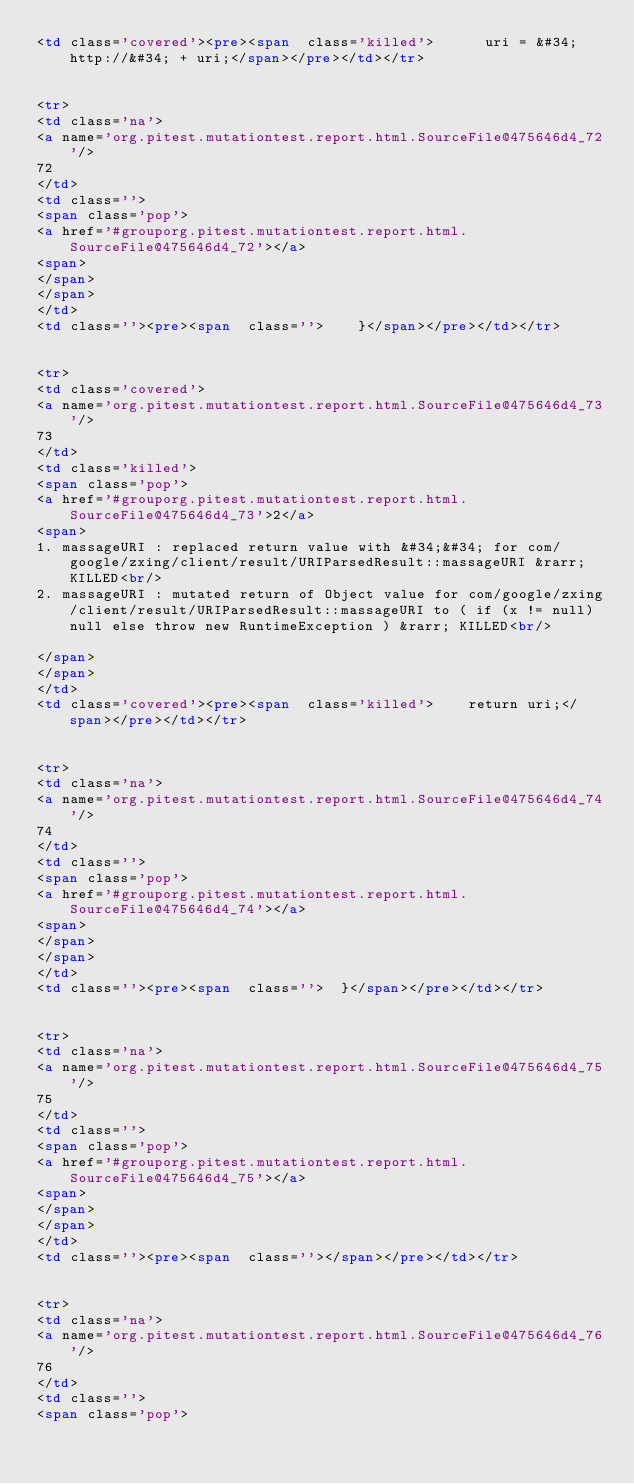Convert code to text. <code><loc_0><loc_0><loc_500><loc_500><_HTML_><td class='covered'><pre><span  class='killed'>      uri = &#34;http://&#34; + uri;</span></pre></td></tr>


<tr>
<td class='na'>
<a name='org.pitest.mutationtest.report.html.SourceFile@475646d4_72'/>
72
</td>
<td class=''>
<span class='pop'>
<a href='#grouporg.pitest.mutationtest.report.html.SourceFile@475646d4_72'></a>
<span>
</span>
</span>
</td>
<td class=''><pre><span  class=''>    }</span></pre></td></tr>


<tr>
<td class='covered'>
<a name='org.pitest.mutationtest.report.html.SourceFile@475646d4_73'/>
73
</td>
<td class='killed'>
<span class='pop'>
<a href='#grouporg.pitest.mutationtest.report.html.SourceFile@475646d4_73'>2</a>
<span>
1. massageURI : replaced return value with &#34;&#34; for com/google/zxing/client/result/URIParsedResult::massageURI &rarr; KILLED<br/>
2. massageURI : mutated return of Object value for com/google/zxing/client/result/URIParsedResult::massageURI to ( if (x != null) null else throw new RuntimeException ) &rarr; KILLED<br/>

</span>
</span>
</td>
<td class='covered'><pre><span  class='killed'>    return uri;</span></pre></td></tr>


<tr>
<td class='na'>
<a name='org.pitest.mutationtest.report.html.SourceFile@475646d4_74'/>
74
</td>
<td class=''>
<span class='pop'>
<a href='#grouporg.pitest.mutationtest.report.html.SourceFile@475646d4_74'></a>
<span>
</span>
</span>
</td>
<td class=''><pre><span  class=''>  }</span></pre></td></tr>


<tr>
<td class='na'>
<a name='org.pitest.mutationtest.report.html.SourceFile@475646d4_75'/>
75
</td>
<td class=''>
<span class='pop'>
<a href='#grouporg.pitest.mutationtest.report.html.SourceFile@475646d4_75'></a>
<span>
</span>
</span>
</td>
<td class=''><pre><span  class=''></span></pre></td></tr>


<tr>
<td class='na'>
<a name='org.pitest.mutationtest.report.html.SourceFile@475646d4_76'/>
76
</td>
<td class=''>
<span class='pop'></code> 